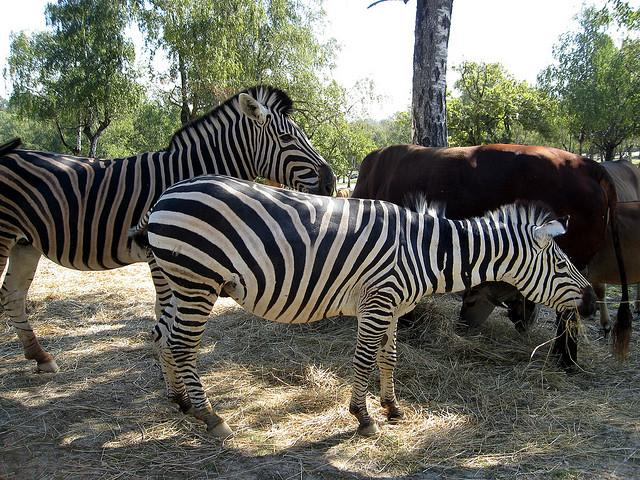Where are the animals?

Choices:
A) cages
B) indoors
C) trailer
D) outdoors outdoors 